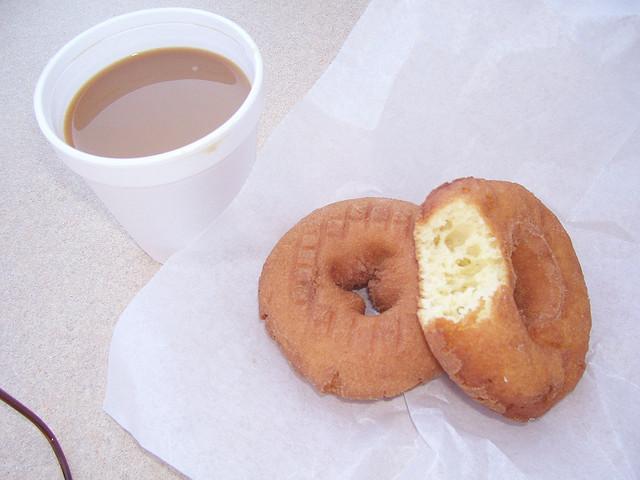Why is there a piece of the donut missing?
Quick response, please. Yes. What is in the cup?
Keep it brief. Coffee. Does the donut have sprinkles?
Be succinct. No. What are they drinking?
Quick response, please. Coffee. How many donuts are pictured?
Write a very short answer. 2. What is the paper product under the meal?
Give a very brief answer. Parchment paper. What's under the paper?
Be succinct. Table. How many donuts are there?
Be succinct. 2. 